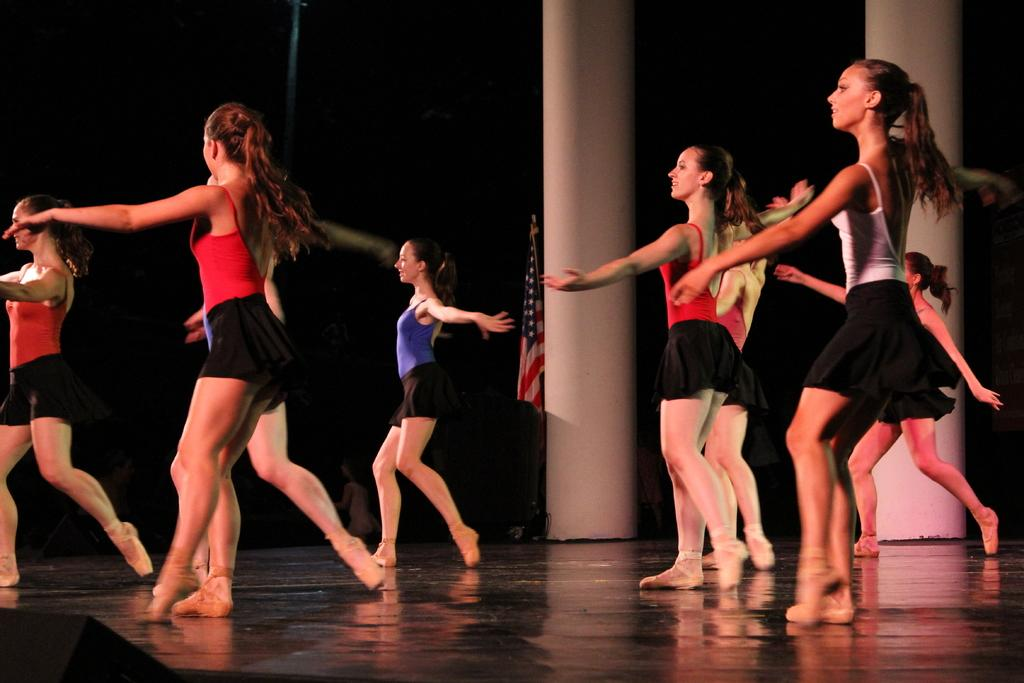Who is present in the image? There are women in the image. What are the women wearing? The women are wearing vests and skirts. What activity are the women engaged in? The women are dancing on a stage. What additional element can be seen in the image? There is a flag in the image. Where is the flag located in relation to other objects? The flag is beside a pillar. What type of stitch is used to sew the women's vests in the image? There is no information about the stitch used to sew the women's vests in the image. 